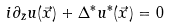Convert formula to latex. <formula><loc_0><loc_0><loc_500><loc_500>i \partial _ { \bar { z } } u ( \vec { x } ) + \Delta ^ { * } u ^ { * } ( \vec { x } ) = 0</formula> 